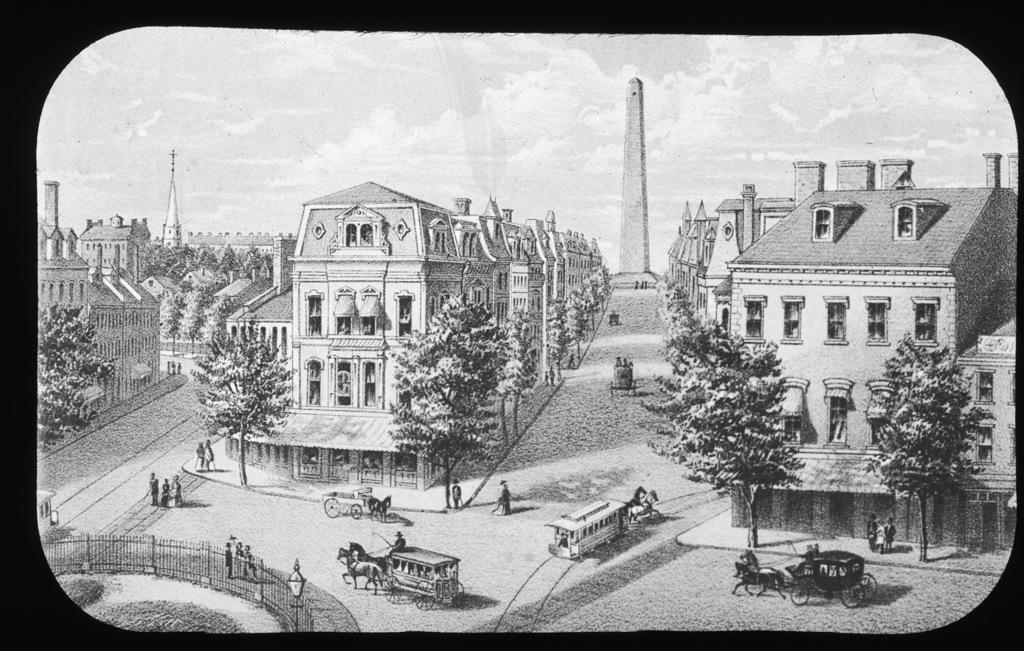What type of photograph is in the image? The image contains a black and white photograph. What can be seen in the photograph? There are buildings and trees visible in the photograph. What else is present in the photograph? There are carts in the photograph. Can you tell me how many people are swimming in the photograph? There is no swimming or people visible in the photograph; it only contains buildings, trees, and carts. 